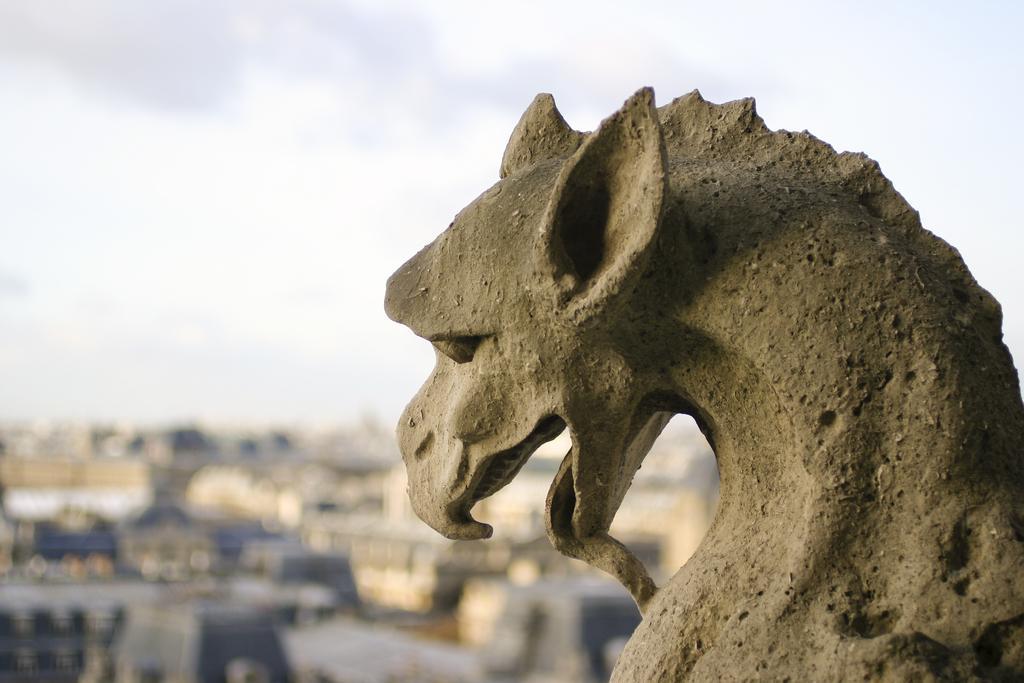Please provide a concise description of this image. In this image I can see it is a statue in the shape of a dragon, at the top it is the cloudy sky. 